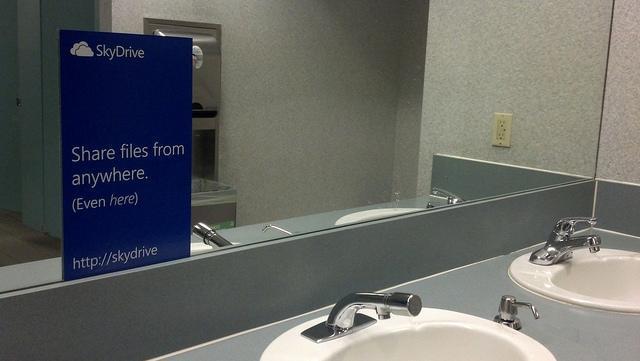How many sinks can you see?
Give a very brief answer. 2. How many cats are shown?
Give a very brief answer. 0. 